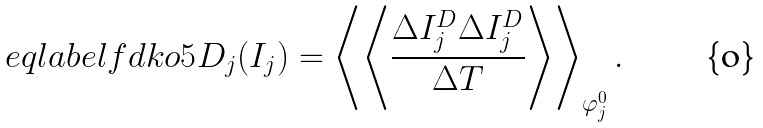<formula> <loc_0><loc_0><loc_500><loc_500>\ e q l a b e l { f d k o 5 } D _ { j } ( I _ { j } ) = \left \langle \left \langle \frac { \Delta I _ { j } ^ { D } \Delta I _ { j } ^ { D } } { \Delta T } \right \rangle \right \rangle _ { \varphi _ { j } ^ { 0 } } .</formula> 